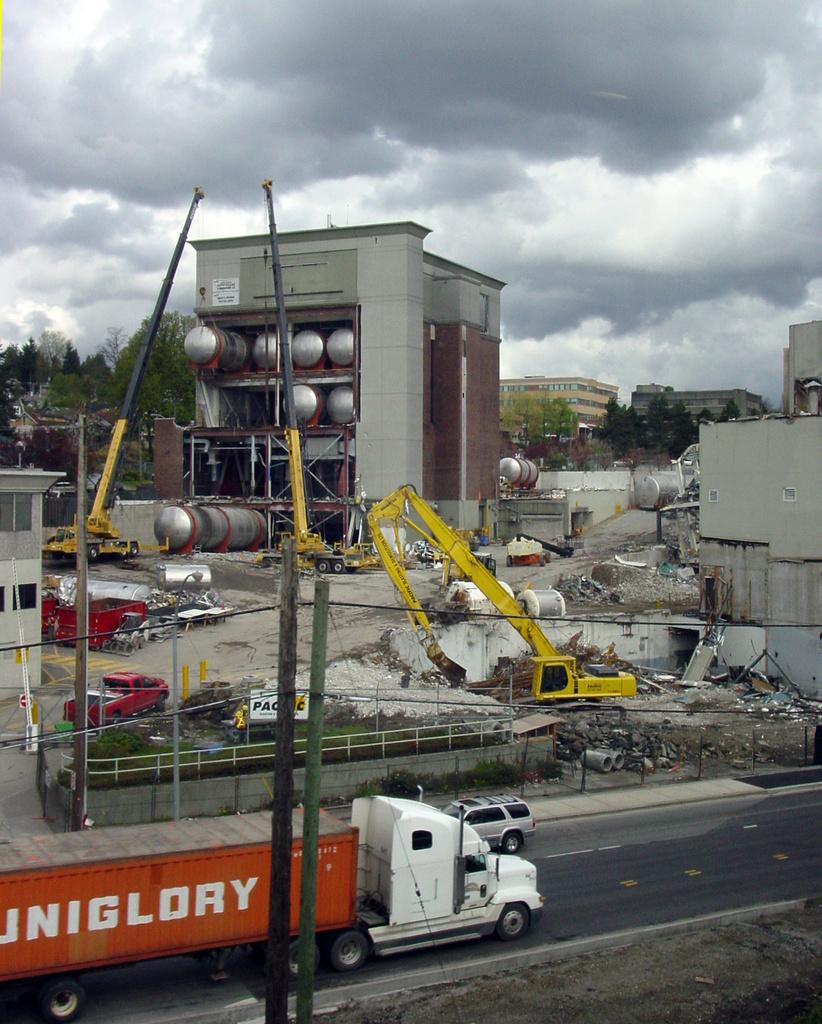What structures can be seen in the image? There are poles, vehicles, cranes, buildings, and a fence visible in the image. What type of equipment is present in the image? Cranes are present in the image. What is the purpose of the board in the image? The purpose of the board in the image is not specified, but it could be used for signage or information. What type of natural elements can be seen in the image? There are plants and trees visible in the image. What is visible in the background of the image? There are buildings, trees, and sky visible in the background of the image. What is the weather like in the image? The presence of clouds in the sky suggests that it might be partly cloudy. What type of music can be heard playing in the background of the image? There is no music present in the image, as it is a still photograph. What type of bait is being used by the fisherman in the image? There is no fisherman or bait present in the image. 